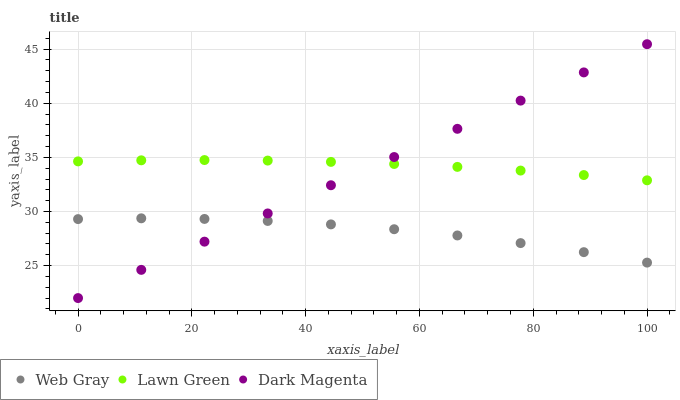Does Web Gray have the minimum area under the curve?
Answer yes or no. Yes. Does Lawn Green have the maximum area under the curve?
Answer yes or no. Yes. Does Dark Magenta have the minimum area under the curve?
Answer yes or no. No. Does Dark Magenta have the maximum area under the curve?
Answer yes or no. No. Is Dark Magenta the smoothest?
Answer yes or no. Yes. Is Web Gray the roughest?
Answer yes or no. Yes. Is Web Gray the smoothest?
Answer yes or no. No. Is Dark Magenta the roughest?
Answer yes or no. No. Does Dark Magenta have the lowest value?
Answer yes or no. Yes. Does Web Gray have the lowest value?
Answer yes or no. No. Does Dark Magenta have the highest value?
Answer yes or no. Yes. Does Web Gray have the highest value?
Answer yes or no. No. Is Web Gray less than Lawn Green?
Answer yes or no. Yes. Is Lawn Green greater than Web Gray?
Answer yes or no. Yes. Does Dark Magenta intersect Lawn Green?
Answer yes or no. Yes. Is Dark Magenta less than Lawn Green?
Answer yes or no. No. Is Dark Magenta greater than Lawn Green?
Answer yes or no. No. Does Web Gray intersect Lawn Green?
Answer yes or no. No. 